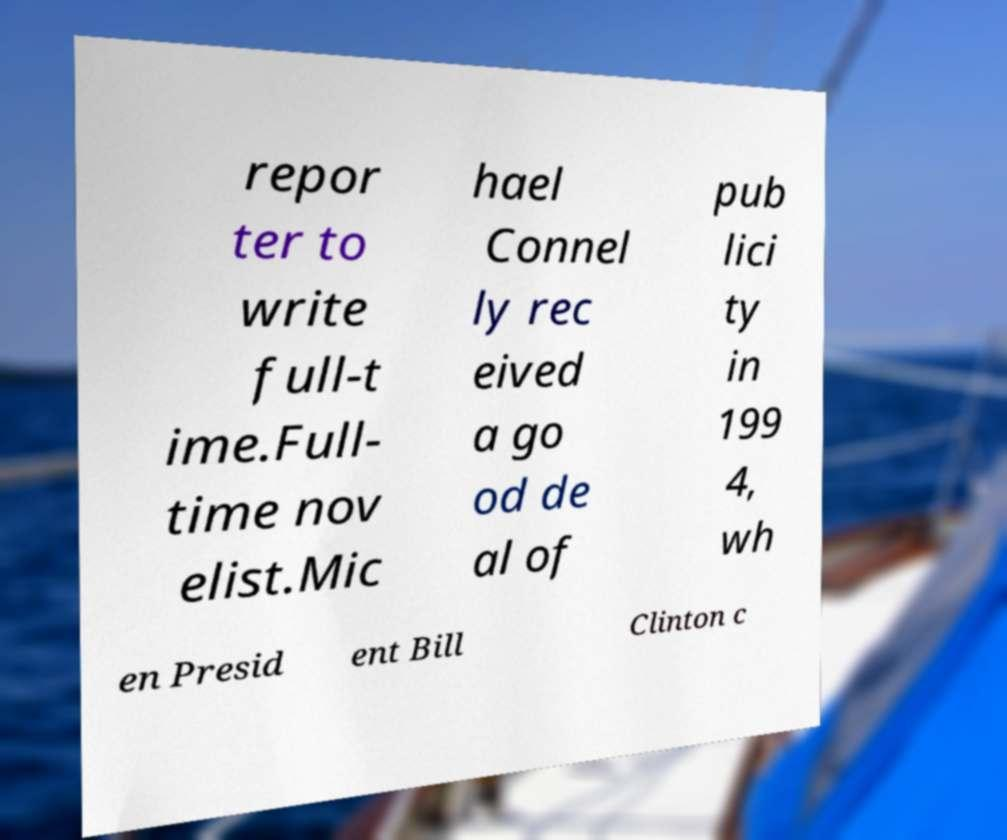Could you assist in decoding the text presented in this image and type it out clearly? repor ter to write full-t ime.Full- time nov elist.Mic hael Connel ly rec eived a go od de al of pub lici ty in 199 4, wh en Presid ent Bill Clinton c 